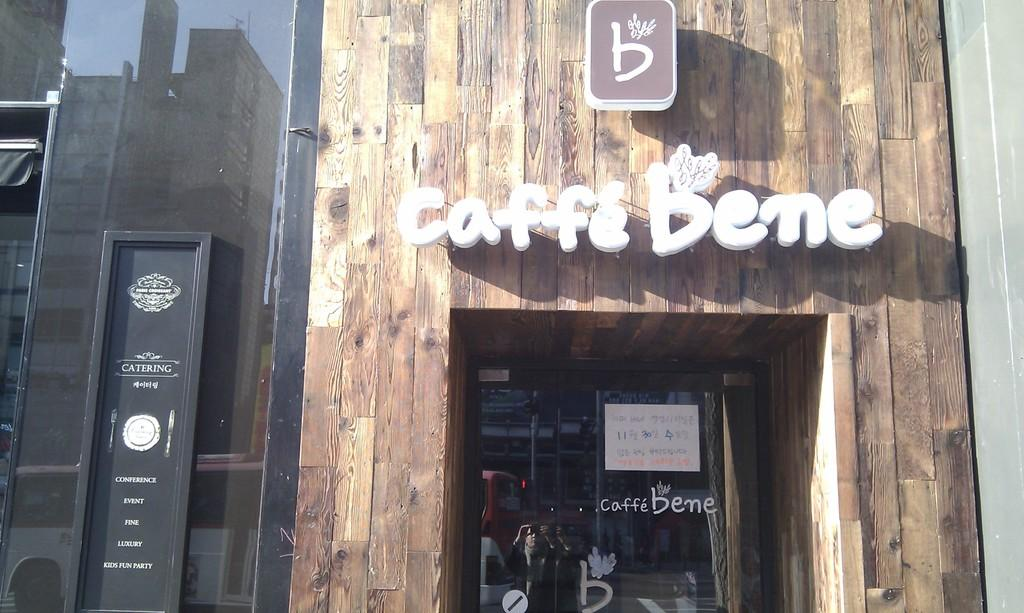What type of establishment is located on the right side of the image? There is a shop on the right side of the image. What is the name of the shop? The shop has "CAFFE BENES" written on it. What color is the door on the left side of the image? There is a black color door on the left side of the image. What type of door is present in the image? There is a glass door in the image. What verse is the writer reciting in front of the shop in the image? There is no writer or verse present in the image. The image only shows a shop with a black door and a glass door. 